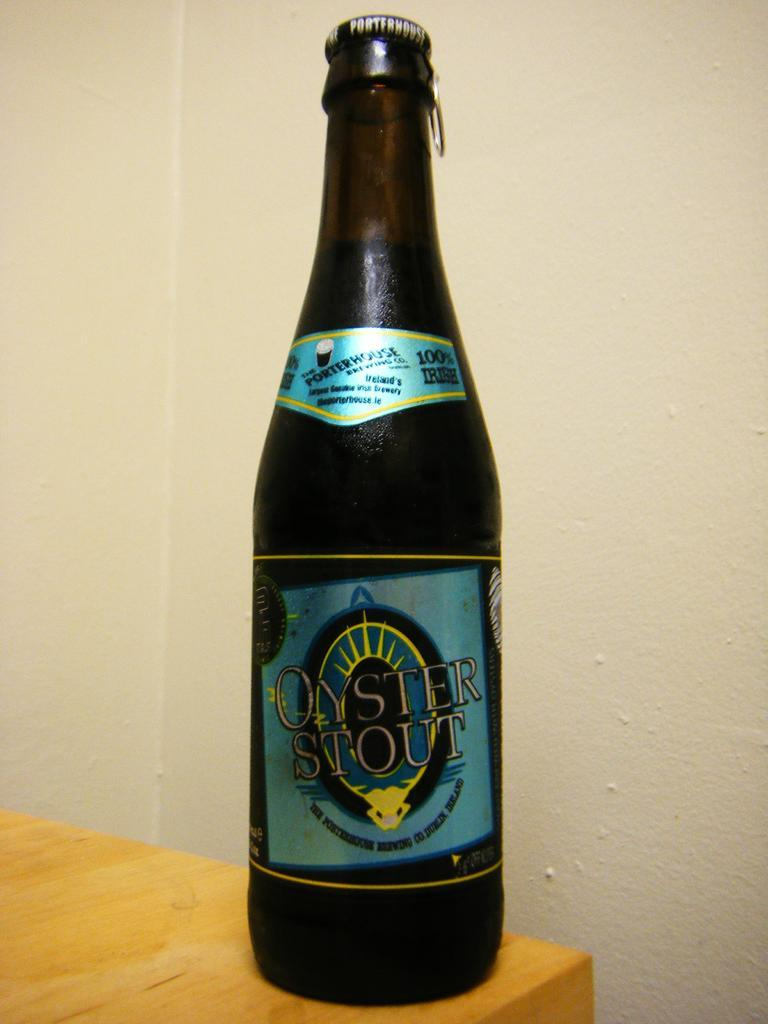<image>
Offer a succinct explanation of the picture presented. A single bottle of Oyster Stout is perched on the edge of a table. 